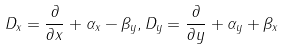Convert formula to latex. <formula><loc_0><loc_0><loc_500><loc_500>{ { D } _ { x } } = \frac { \partial } { \partial x } + { { \alpha } _ { x } } - { { \beta } _ { y } } , { { D } _ { y } } = \frac { \partial } { \partial y } + { { \alpha } _ { y } } + { { \beta } _ { x } }</formula> 